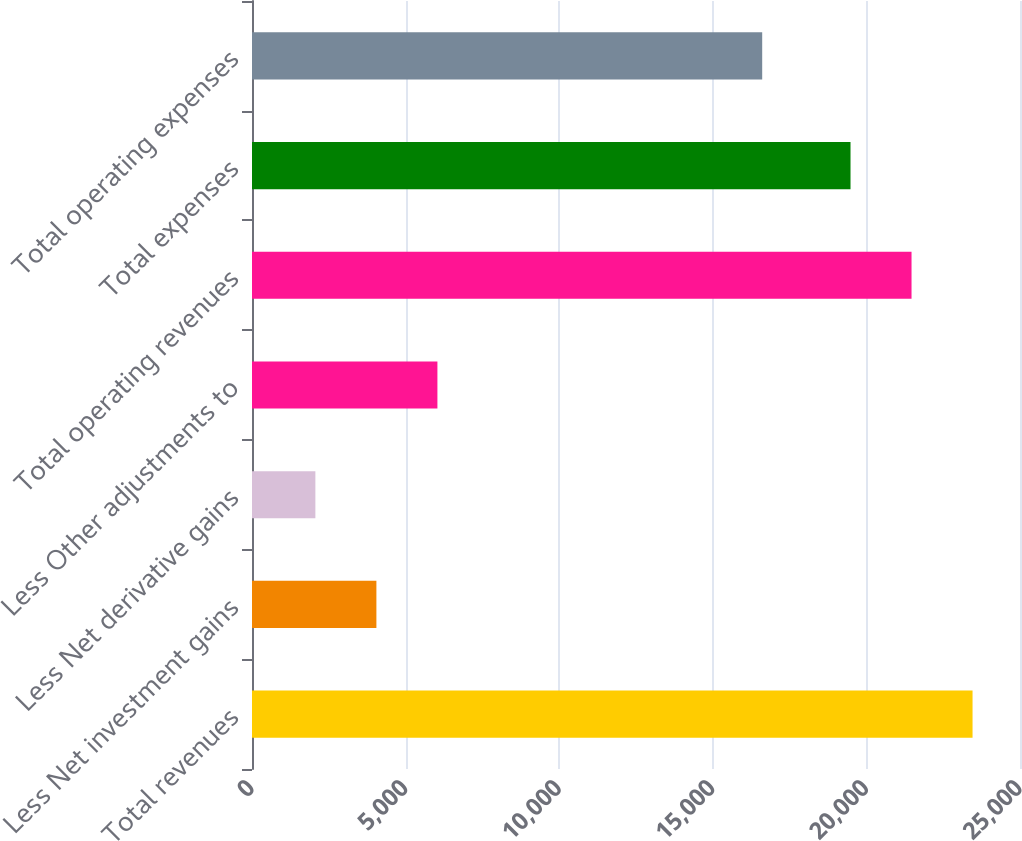Convert chart. <chart><loc_0><loc_0><loc_500><loc_500><bar_chart><fcel>Total revenues<fcel>Less Net investment gains<fcel>Less Net derivative gains<fcel>Less Other adjustments to<fcel>Total operating revenues<fcel>Total expenses<fcel>Total operating expenses<nl><fcel>23455.4<fcel>4049.4<fcel>2063.2<fcel>6035.6<fcel>21469.2<fcel>19483<fcel>16608<nl></chart> 